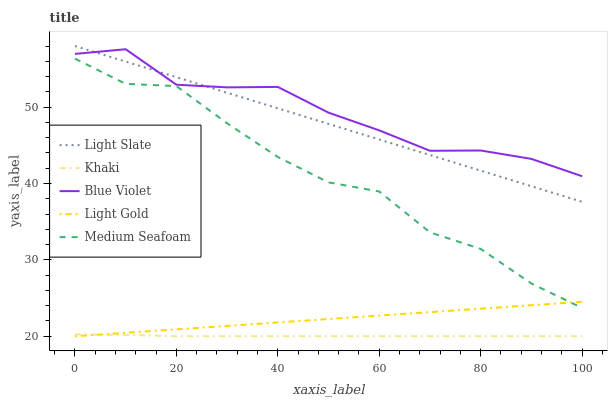Does Khaki have the minimum area under the curve?
Answer yes or no. Yes. Does Blue Violet have the maximum area under the curve?
Answer yes or no. Yes. Does Light Gold have the minimum area under the curve?
Answer yes or no. No. Does Light Gold have the maximum area under the curve?
Answer yes or no. No. Is Light Gold the smoothest?
Answer yes or no. Yes. Is Medium Seafoam the roughest?
Answer yes or no. Yes. Is Khaki the smoothest?
Answer yes or no. No. Is Khaki the roughest?
Answer yes or no. No. Does Khaki have the lowest value?
Answer yes or no. Yes. Does Medium Seafoam have the lowest value?
Answer yes or no. No. Does Light Slate have the highest value?
Answer yes or no. Yes. Does Light Gold have the highest value?
Answer yes or no. No. Is Light Gold less than Blue Violet?
Answer yes or no. Yes. Is Blue Violet greater than Light Gold?
Answer yes or no. Yes. Does Light Gold intersect Medium Seafoam?
Answer yes or no. Yes. Is Light Gold less than Medium Seafoam?
Answer yes or no. No. Is Light Gold greater than Medium Seafoam?
Answer yes or no. No. Does Light Gold intersect Blue Violet?
Answer yes or no. No. 